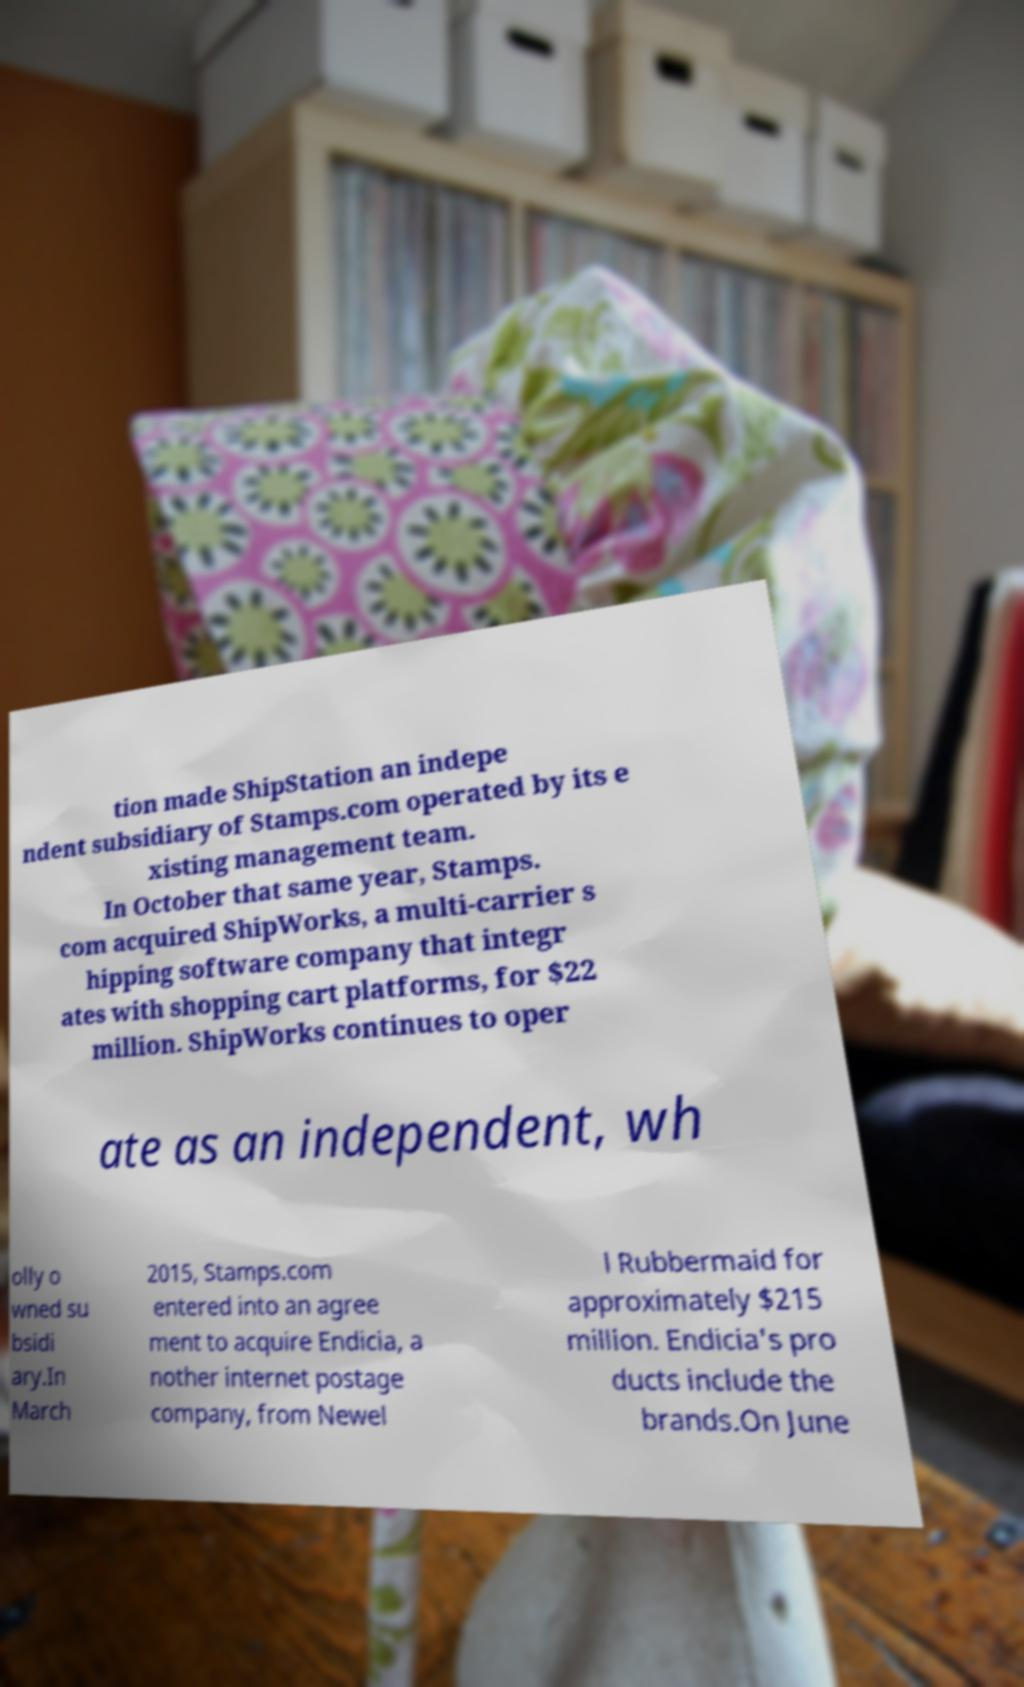Please read and relay the text visible in this image. What does it say? tion made ShipStation an indepe ndent subsidiary of Stamps.com operated by its e xisting management team. In October that same year, Stamps. com acquired ShipWorks, a multi-carrier s hipping software company that integr ates with shopping cart platforms, for $22 million. ShipWorks continues to oper ate as an independent, wh olly o wned su bsidi ary.In March 2015, Stamps.com entered into an agree ment to acquire Endicia, a nother internet postage company, from Newel l Rubbermaid for approximately $215 million. Endicia's pro ducts include the brands.On June 